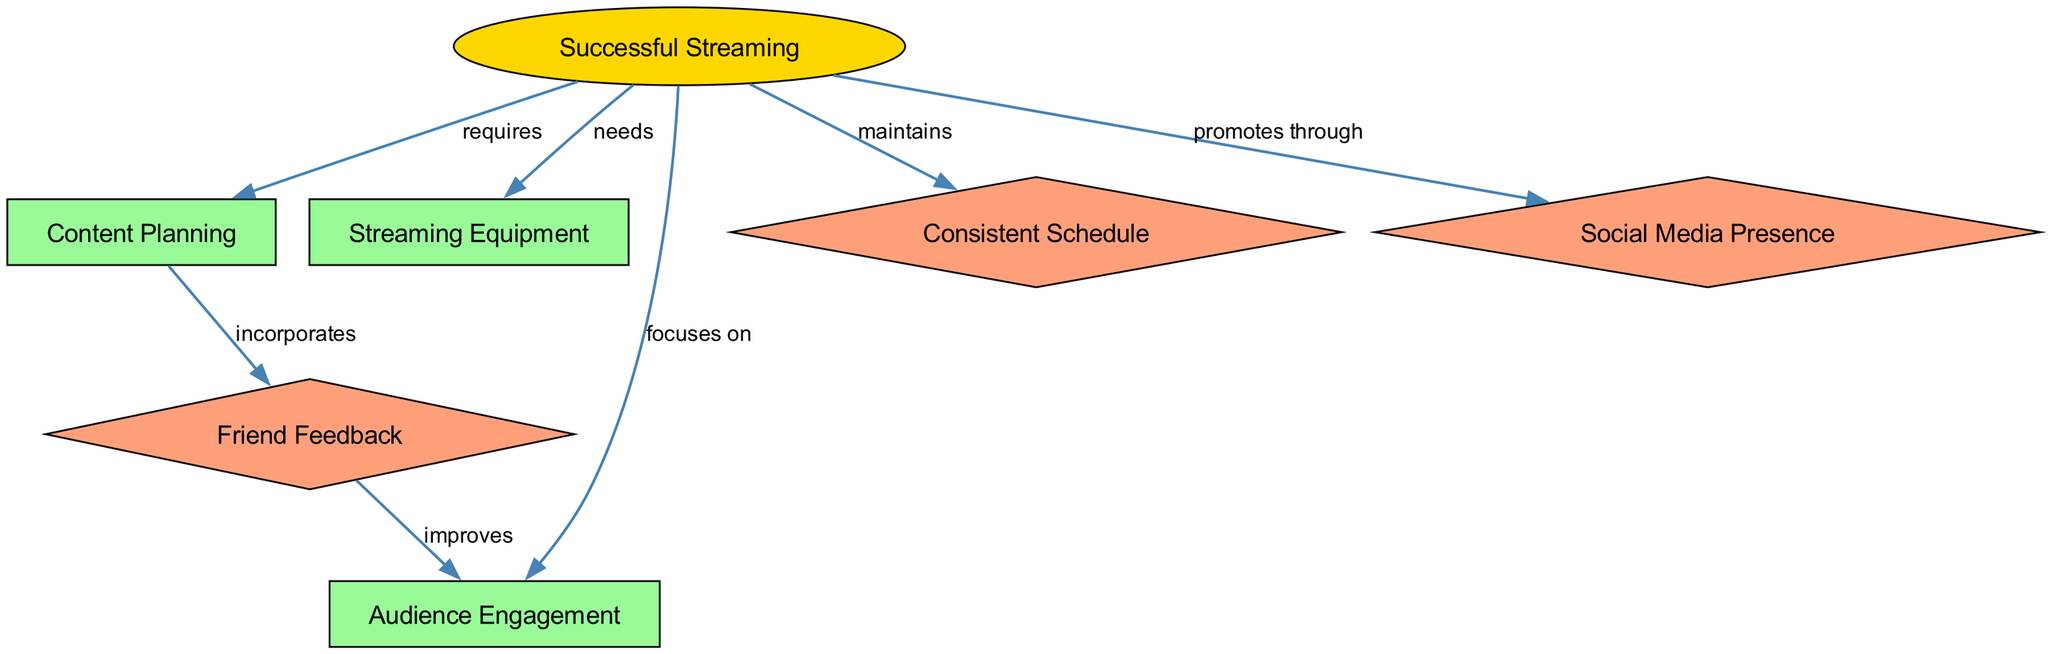What is the main focus of successful streaming? The diagram indicates that "engagement" is emphasized under "Successful Streaming," illustrating that audience engagement is a critical element of streaming success.
Answer: engagement How many nodes are in the diagram? By counting the nodes listed in the data, we determine there are a total of six nodes representing various aspects of content creation and streaming.
Answer: six What element incorporates feedback from friends? The diagram shows that "Content Planning" incorporates "Friend Feedback," highlighting the importance of involving friends in the planning stage for more audience-tailored content.
Answer: Friend Feedback What is required for successful streaming? The edges connected to "Successful Streaming" indicate that it requires "Content Planning" and "Streaming Equipment," reflecting the foundational aspects necessary for successful streaming.
Answer: Content Planning What type of media presence does streaming promote through? The diagram illustrates that successful streaming promotes itself through "Social Media Presence," underscoring the role of social media in attracting and retaining an audience.
Answer: Social Media Presence Which element focuses on improving audience engagement? The relationship displayed shows that "Friend Feedback" improves "Audience Engagement," signifying that feedback from friends can lead to better ways to engage the audience during streams.
Answer: improves What does successful streaming maintain? The diagram specifies that "Consistent Schedule" is maintained by successful streaming, indicating that regular scheduling is key to building and retaining an audience.
Answer: Consistent Schedule How does friend feedback relate to content planning? Analyzing the relationship, "Friend Feedback" is shown as incorporated in "Content Planning," which suggests that feedback from friends is directly used to shape the content that will be created.
Answer: incorporates 